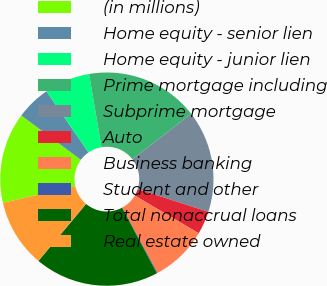<chart> <loc_0><loc_0><loc_500><loc_500><pie_chart><fcel>(in millions)<fcel>Home equity - senior lien<fcel>Home equity - junior lien<fcel>Prime mortgage including<fcel>Subprime mortgage<fcel>Auto<fcel>Business banking<fcel>Student and other<fcel>Total nonaccrual loans<fcel>Real estate owned<nl><fcel>13.75%<fcel>5.23%<fcel>6.93%<fcel>17.16%<fcel>15.46%<fcel>3.52%<fcel>8.64%<fcel>0.11%<fcel>18.86%<fcel>10.34%<nl></chart> 